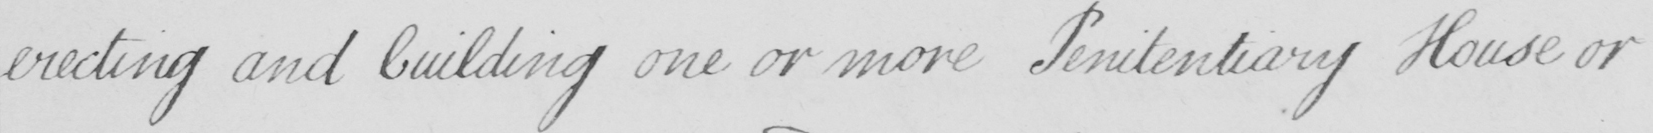What text is written in this handwritten line? erecting and building one or more Penitentiary House or 